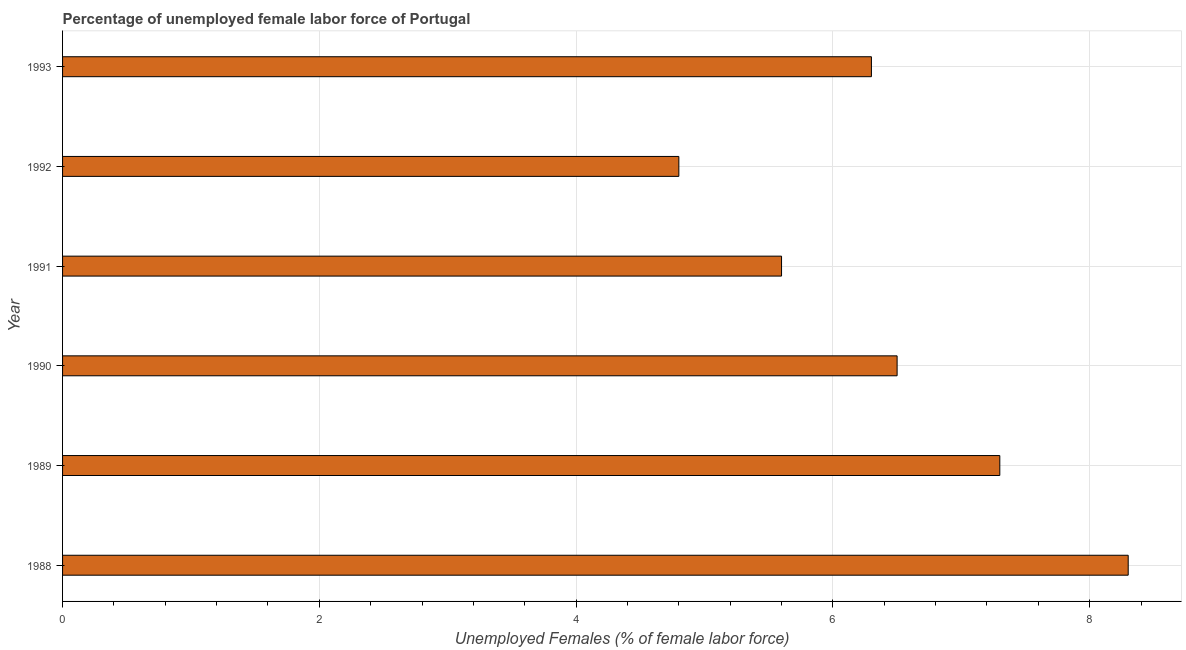What is the title of the graph?
Your answer should be compact. Percentage of unemployed female labor force of Portugal. What is the label or title of the X-axis?
Offer a terse response. Unemployed Females (% of female labor force). What is the label or title of the Y-axis?
Provide a succinct answer. Year. What is the total unemployed female labour force in 1993?
Provide a short and direct response. 6.3. Across all years, what is the maximum total unemployed female labour force?
Make the answer very short. 8.3. Across all years, what is the minimum total unemployed female labour force?
Your answer should be compact. 4.8. In which year was the total unemployed female labour force maximum?
Provide a succinct answer. 1988. What is the sum of the total unemployed female labour force?
Make the answer very short. 38.8. What is the difference between the total unemployed female labour force in 1990 and 1991?
Offer a very short reply. 0.9. What is the average total unemployed female labour force per year?
Offer a very short reply. 6.47. What is the median total unemployed female labour force?
Give a very brief answer. 6.4. Do a majority of the years between 1991 and 1993 (inclusive) have total unemployed female labour force greater than 2.4 %?
Make the answer very short. Yes. What is the ratio of the total unemployed female labour force in 1989 to that in 1990?
Offer a terse response. 1.12. Is the total unemployed female labour force in 1990 less than that in 1993?
Your response must be concise. No. Is the difference between the total unemployed female labour force in 1988 and 1992 greater than the difference between any two years?
Keep it short and to the point. Yes. What is the difference between the highest and the lowest total unemployed female labour force?
Provide a short and direct response. 3.5. How many years are there in the graph?
Give a very brief answer. 6. Are the values on the major ticks of X-axis written in scientific E-notation?
Offer a terse response. No. What is the Unemployed Females (% of female labor force) of 1988?
Make the answer very short. 8.3. What is the Unemployed Females (% of female labor force) of 1989?
Your answer should be very brief. 7.3. What is the Unemployed Females (% of female labor force) in 1991?
Make the answer very short. 5.6. What is the Unemployed Females (% of female labor force) of 1992?
Provide a short and direct response. 4.8. What is the Unemployed Females (% of female labor force) of 1993?
Provide a short and direct response. 6.3. What is the difference between the Unemployed Females (% of female labor force) in 1988 and 1991?
Offer a terse response. 2.7. What is the difference between the Unemployed Females (% of female labor force) in 1988 and 1992?
Make the answer very short. 3.5. What is the difference between the Unemployed Females (% of female labor force) in 1989 and 1990?
Ensure brevity in your answer.  0.8. What is the difference between the Unemployed Females (% of female labor force) in 1989 and 1991?
Provide a succinct answer. 1.7. What is the difference between the Unemployed Females (% of female labor force) in 1989 and 1993?
Keep it short and to the point. 1. What is the difference between the Unemployed Females (% of female labor force) in 1990 and 1993?
Give a very brief answer. 0.2. What is the difference between the Unemployed Females (% of female labor force) in 1992 and 1993?
Ensure brevity in your answer.  -1.5. What is the ratio of the Unemployed Females (% of female labor force) in 1988 to that in 1989?
Your answer should be compact. 1.14. What is the ratio of the Unemployed Females (% of female labor force) in 1988 to that in 1990?
Provide a short and direct response. 1.28. What is the ratio of the Unemployed Females (% of female labor force) in 1988 to that in 1991?
Make the answer very short. 1.48. What is the ratio of the Unemployed Females (% of female labor force) in 1988 to that in 1992?
Your response must be concise. 1.73. What is the ratio of the Unemployed Females (% of female labor force) in 1988 to that in 1993?
Provide a succinct answer. 1.32. What is the ratio of the Unemployed Females (% of female labor force) in 1989 to that in 1990?
Keep it short and to the point. 1.12. What is the ratio of the Unemployed Females (% of female labor force) in 1989 to that in 1991?
Provide a short and direct response. 1.3. What is the ratio of the Unemployed Females (% of female labor force) in 1989 to that in 1992?
Your answer should be compact. 1.52. What is the ratio of the Unemployed Females (% of female labor force) in 1989 to that in 1993?
Provide a short and direct response. 1.16. What is the ratio of the Unemployed Females (% of female labor force) in 1990 to that in 1991?
Provide a succinct answer. 1.16. What is the ratio of the Unemployed Females (% of female labor force) in 1990 to that in 1992?
Provide a short and direct response. 1.35. What is the ratio of the Unemployed Females (% of female labor force) in 1990 to that in 1993?
Keep it short and to the point. 1.03. What is the ratio of the Unemployed Females (% of female labor force) in 1991 to that in 1992?
Ensure brevity in your answer.  1.17. What is the ratio of the Unemployed Females (% of female labor force) in 1991 to that in 1993?
Make the answer very short. 0.89. What is the ratio of the Unemployed Females (% of female labor force) in 1992 to that in 1993?
Make the answer very short. 0.76. 